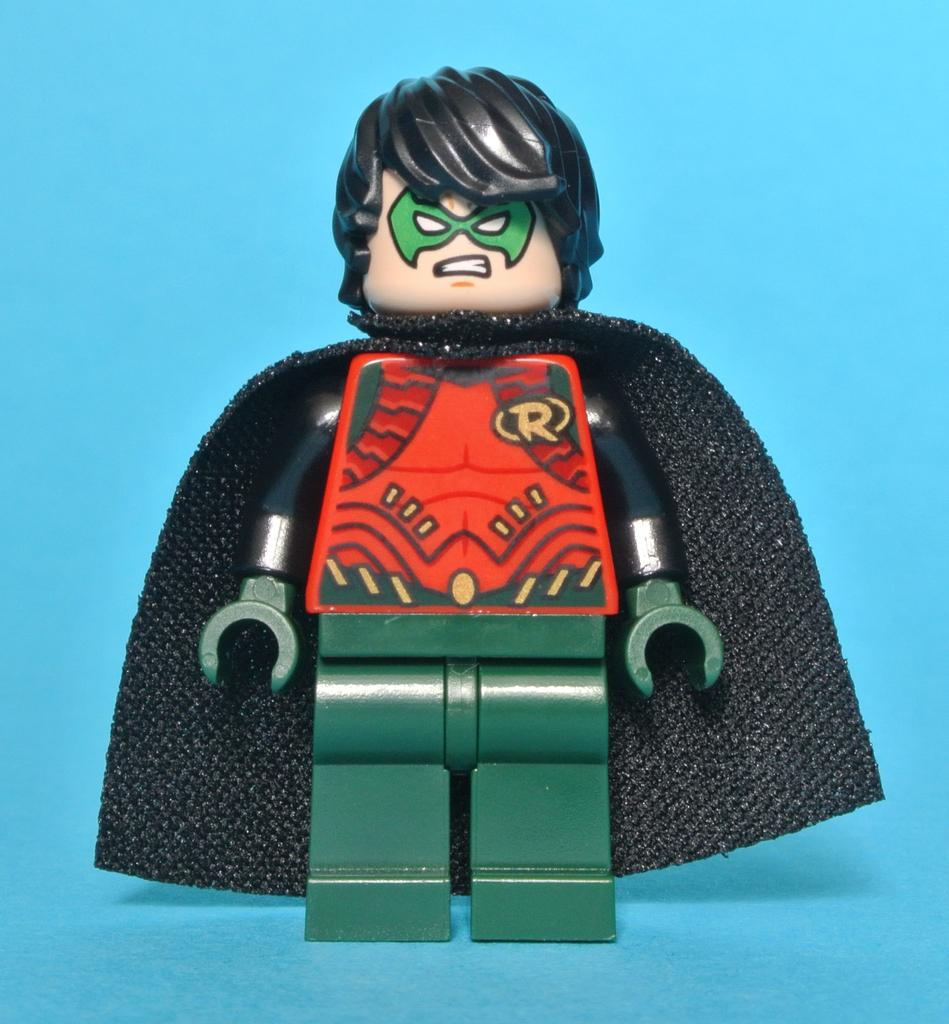What is the main object in the image? There is a toy in the image. Can you describe the colors of the toy? The toy has black, red, and green colors. What is the value of the toy in the image? The value of the toy cannot be determined from the image alone, as it depends on various factors such as its condition, rarity, and demand. 